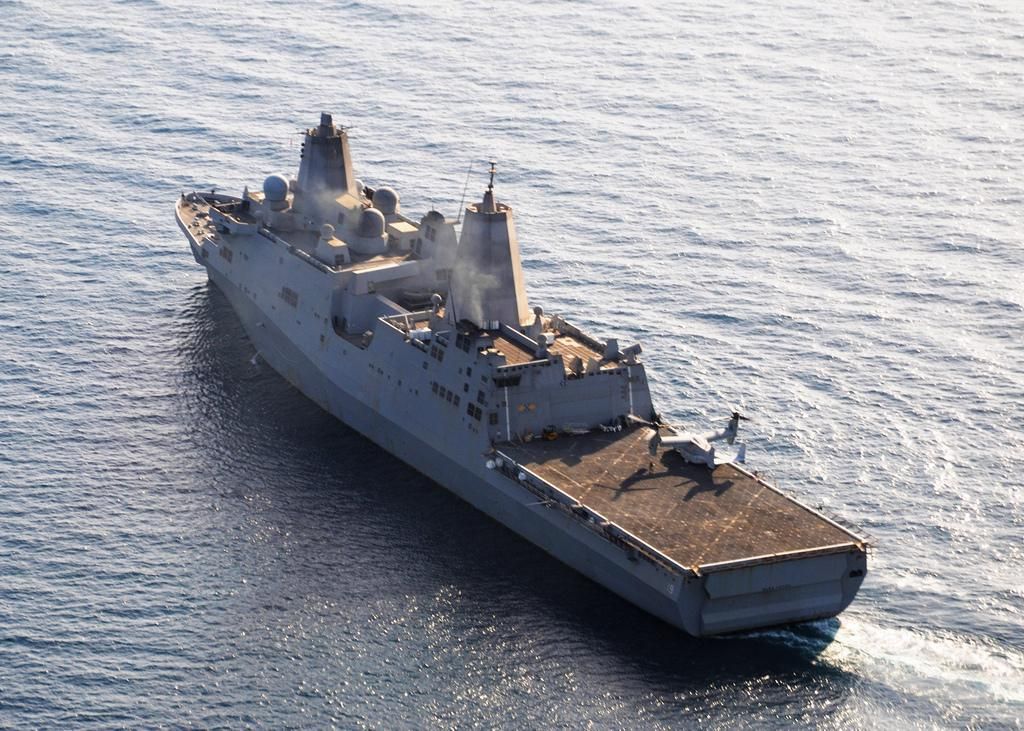What is present in the image that is not solid? There is water in the image. What type of vehicle can be seen in the image? There is a ship in the image. What is the ship doing in the water? The ship is moving in the water. What type of cook is present on the ship in the image? There is no cook present on the ship in the image. What emotion can be seen on the faces of the people on the ship in the image? There are no faces or emotions visible in the image, as it only shows the ship and water. 